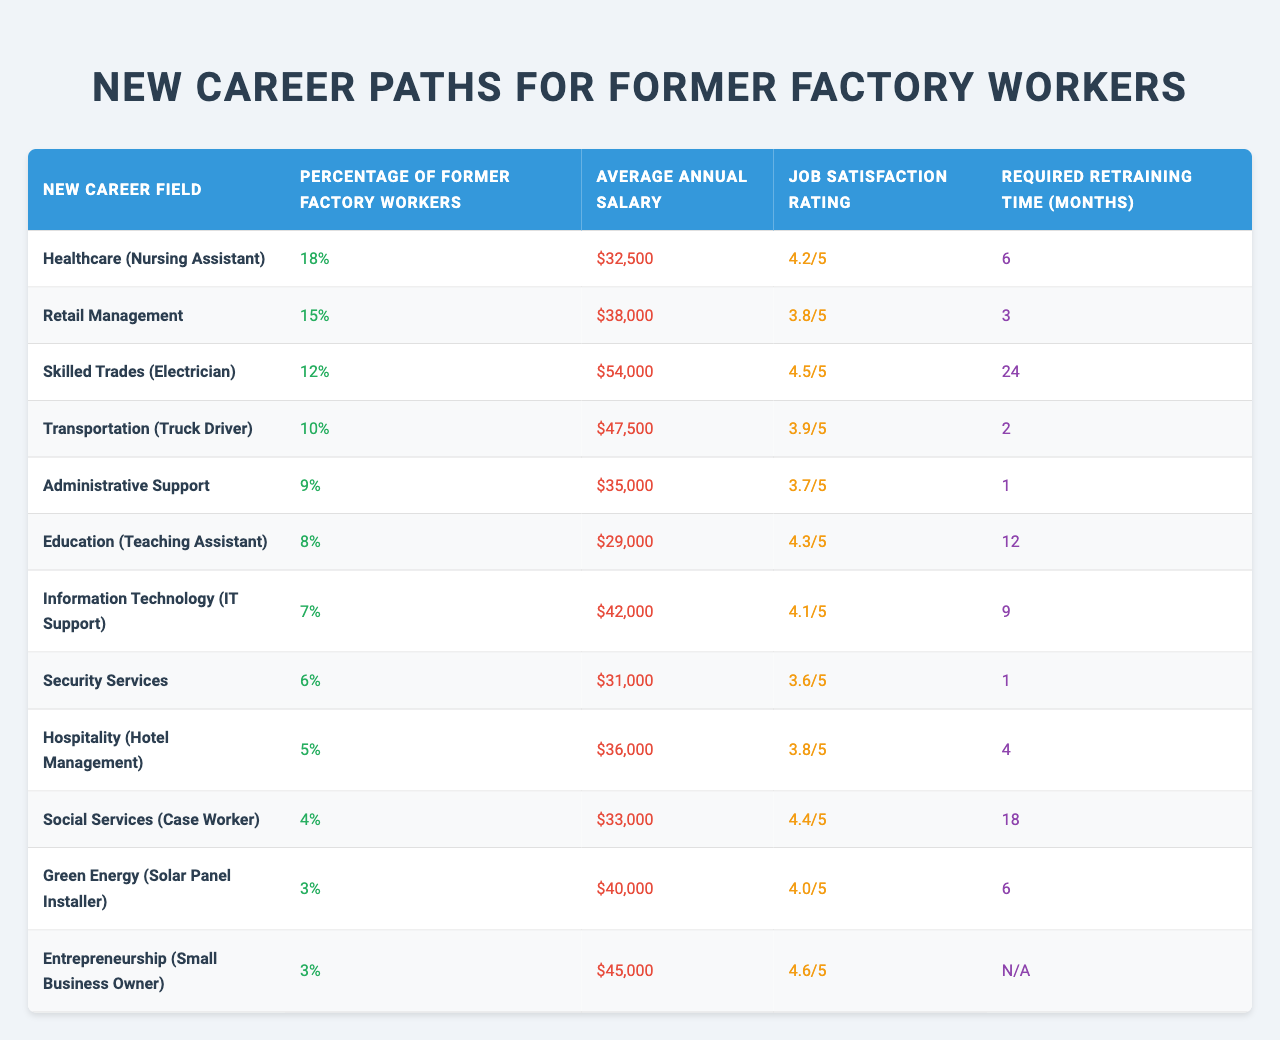What is the most common new career field for former factory workers? The career field with the highest percentage of former factory workers is Healthcare (Nursing Assistant) at 18%.
Answer: Healthcare (Nursing Assistant) What is the average annual salary for skilled trades workers? The average annual salary for skilled trades (Electrician) is $54,000, which is identified under that category in the table.
Answer: $54,000 Which new career field has the lowest job satisfaction rating? Reviewing the job satisfaction ratings, Security Services has the lowest rating of 3.6/5 compared to the other fields.
Answer: Security Services What percentage of former factory workers transitioned to education roles? The percentage of former factory workers who became teaching assistants in education is 8%, as shown in the data.
Answer: 8% What is the average required retraining time for the top three career fields? The average retraining time is calculated as follows: (6 + 3 + 24) / 3 = 33 / 3 = 11 months. The top three fields are Healthcare, Retail Management, and Skilled Trades.
Answer: 11 months Is the average annual salary higher in transportation than in retail management? Yes, the average annual salary in Transportation (Truck Driver) is $47,500, which is higher than the average salary in Retail Management at $38,000.
Answer: Yes Which new career field offers the highest job satisfaction rating, and what is it? The field with the highest job satisfaction rating is Entrepreneurship (Small Business Owner) at 4.6/5.
Answer: Entrepreneurship (Small Business Owner) How many months of retraining do former factory workers need on average for hospitality compared to social services? For Hospitality (Hotel Management), the retraining time is 4 months, while for Social Services (Case Worker), it's 18 months. The difference in retraining time is 18 - 4 = 14 months, so it takes 14 more months for Social Services.
Answer: 14 months Which new career field has a higher average salary: Information Technology or Healthcare? The average salary for Information Technology (IT Support) is $42,000, while for Healthcare (Nursing Assistant), it's $32,500; hence, IT has the higher salary.
Answer: Information Technology What is the ratio of former factory workers now in transportation to those in skilled trades? The percentage of former factory workers in Transportation is 10%, and in Skilled Trades is 12%. The ratio is 10:12, simplified to 5:6.
Answer: 5:6 